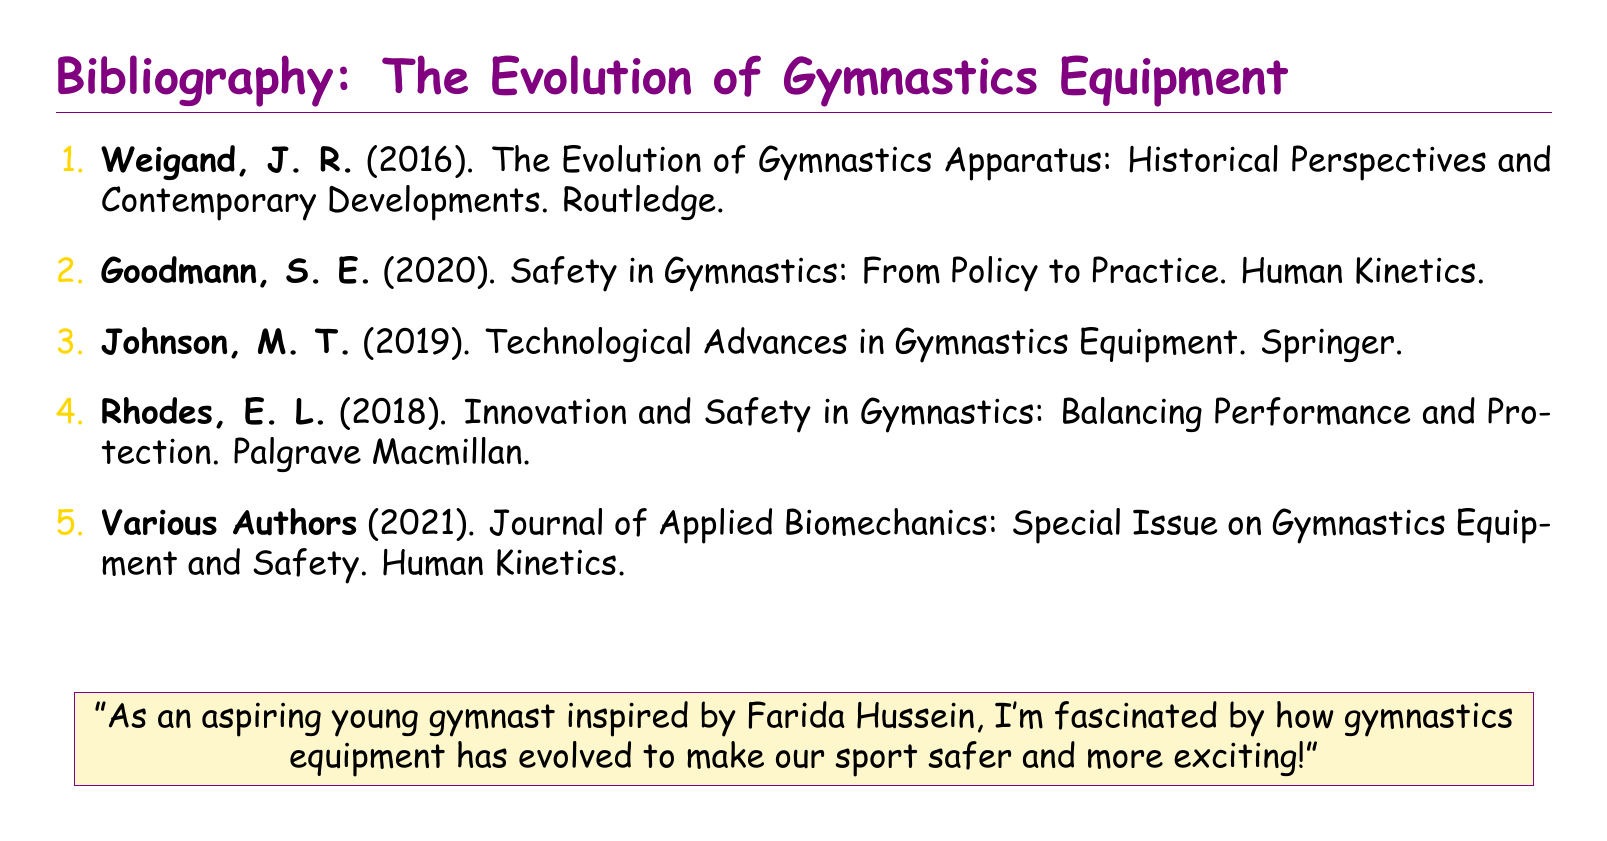What is the first author's name? The first author's name listed in the bibliography is J. R. Weigand.
Answer: J. R. Weigand What year was "Safety in Gymnastics: From Policy to Practice" published? The publication year of the book is mentioned next to the title, which is 2020.
Answer: 2020 Which publisher released "Technological Advances in Gymnastics Equipment"? The publisher is noted in the citation for the book by M. T. Johnson.
Answer: Springer What color is used for the section titles in the document? The section titles are styled in a specific color, which is gymnastic purple.
Answer: gymnastic purple How many works are listed in the bibliography? The total number of entries in the bibliography is counted based on the enumeration format.
Answer: 5 What is the main theme of the bibliography? The main theme can be derived from the title "The Evolution of Gymnastics Equipment."
Answer: Evolution of Gymnastics Equipment Who are the authors of the special journal issue mentioned? The authors are listed as "Various Authors" for the journal citation.
Answer: Various Authors What type of document is this? The document is characterized as a bibliography based on its structure and content.
Answer: Bibliography 